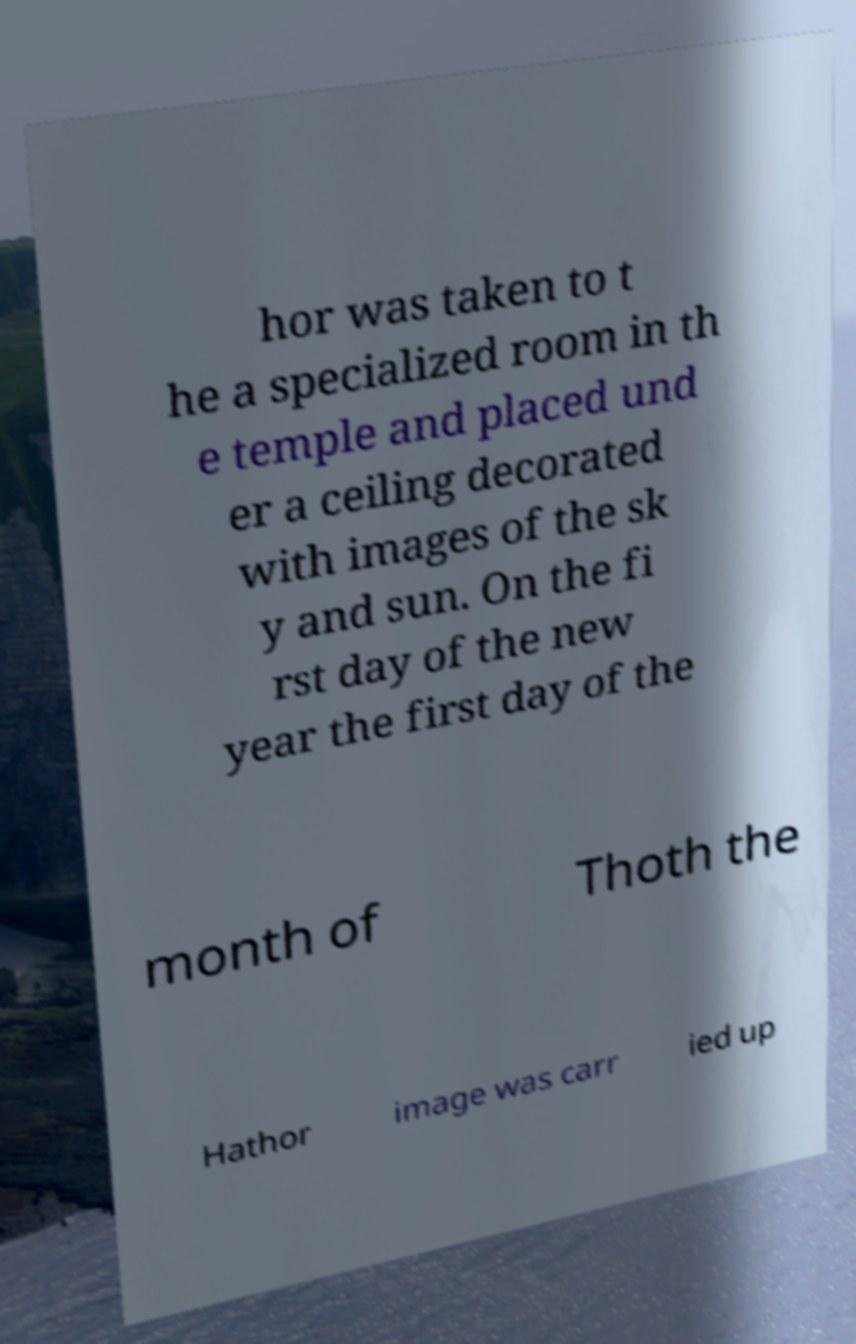Please read and relay the text visible in this image. What does it say? hor was taken to t he a specialized room in th e temple and placed und er a ceiling decorated with images of the sk y and sun. On the fi rst day of the new year the first day of the month of Thoth the Hathor image was carr ied up 